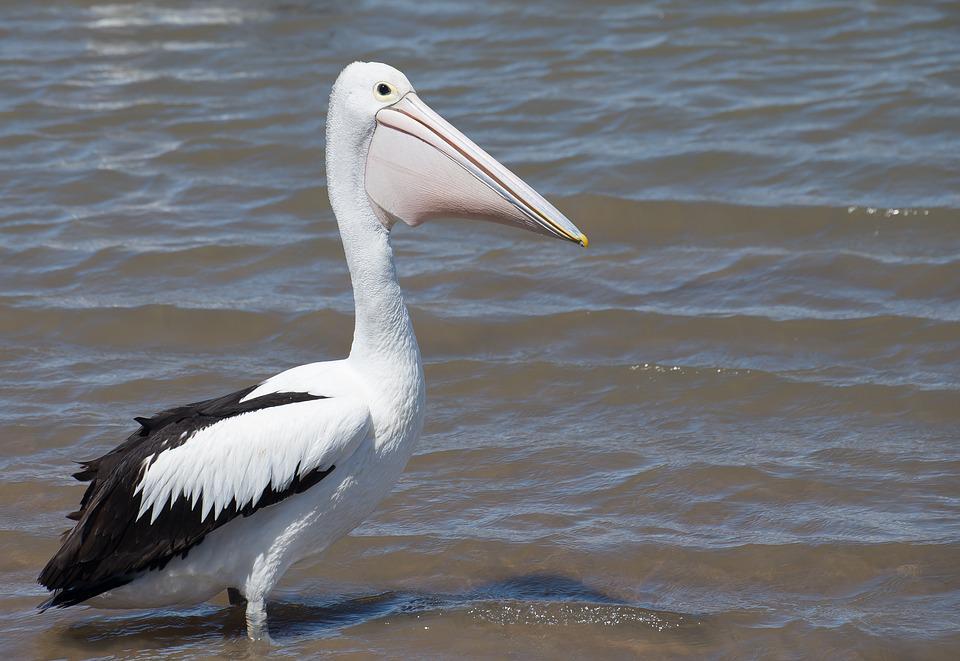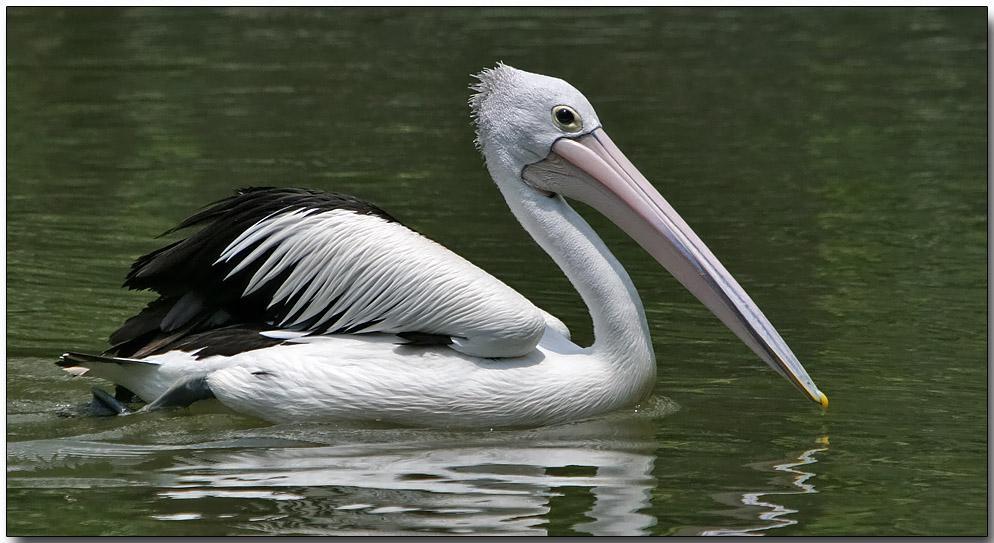The first image is the image on the left, the second image is the image on the right. Given the left and right images, does the statement "One of the images contains exactly two birds." hold true? Answer yes or no. No. 